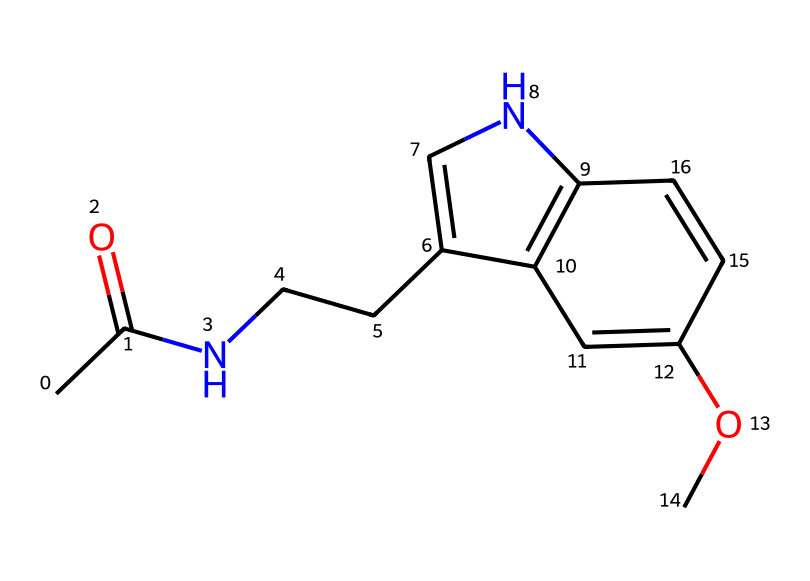What is the name of this chemical? The provided SMILES structure corresponds to the chemical melatonin, which is a well-known hormone involved in regulating sleep-wake cycles.
Answer: melatonin How many nitrogen atoms are present in this structure? By examining the structure represented in the SMILES notation, there are two nitrogen atoms, one in the cyclic structure and one connected to the carbon chain.
Answer: 2 What type of functional group is present in melatonin? The structure contains an amide functional group, indicated by the presence of both a carbonyl and a nitrogen connected to the carbon chain.
Answer: amide Which part of the chemical is critical for its role in regulating sleep? The indole ring in the structure plays a crucial role in melatonin’s function as it is involved in receptor binding that influences sleep regulation.
Answer: indole ring What effect does late-night gaming have on melatonin production? Late-night gaming typically results in reduced melatonin production due to blue light exposure from screens, which interferes with the hormonal secretion process from the pineal gland.
Answer: reduced production How might the presence of an alkyl group affect the solubility of melatonin? The presence of an alkyl (specifically the ethyl group in this case) increases the hydrophobic characteristics and can enhance lipid solubility, affecting how melatonin distributes in biological systems.
Answer: increases solubility What type of chemical compound is melatonin predominantly classified as? Melatonin is classified as a biogenic amine because it is derived from the amino acid tryptophan and has a key role in biological functions like sleep regulation.
Answer: biogenic amine 